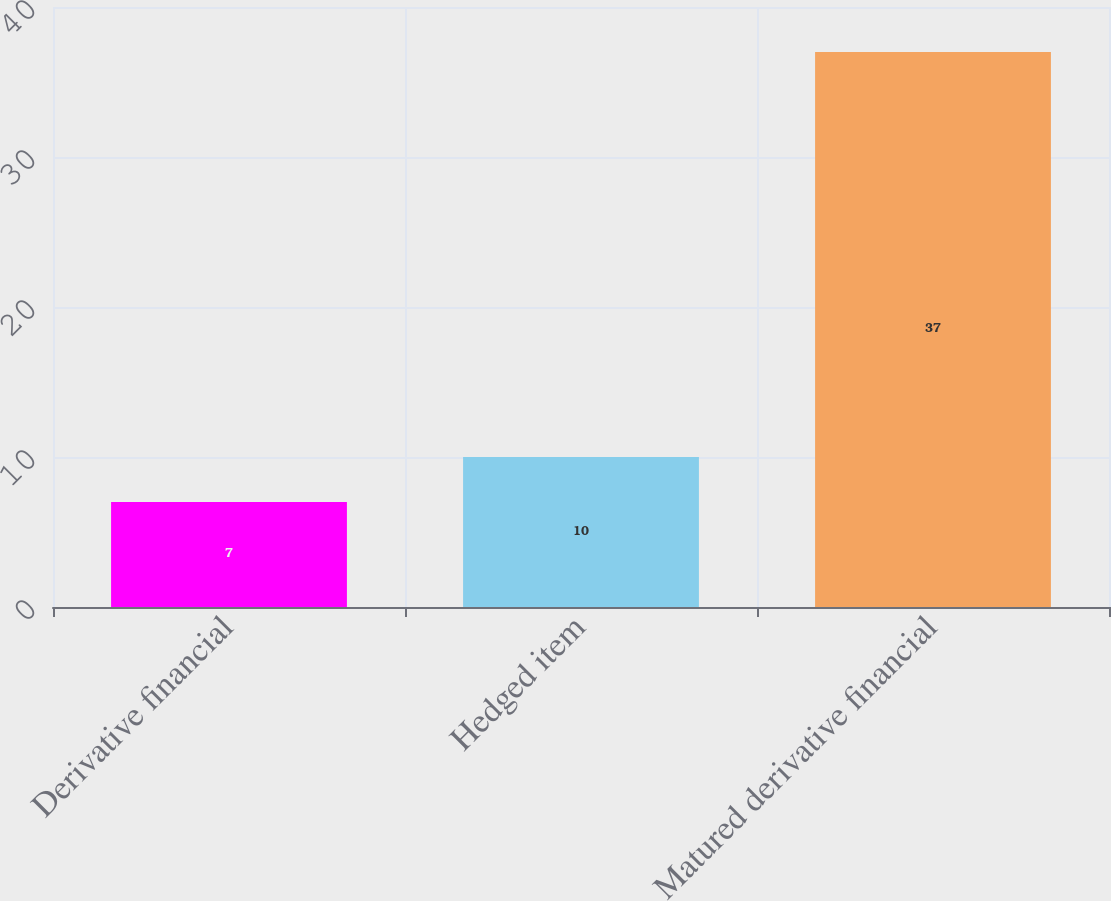<chart> <loc_0><loc_0><loc_500><loc_500><bar_chart><fcel>Derivative financial<fcel>Hedged item<fcel>Matured derivative financial<nl><fcel>7<fcel>10<fcel>37<nl></chart> 